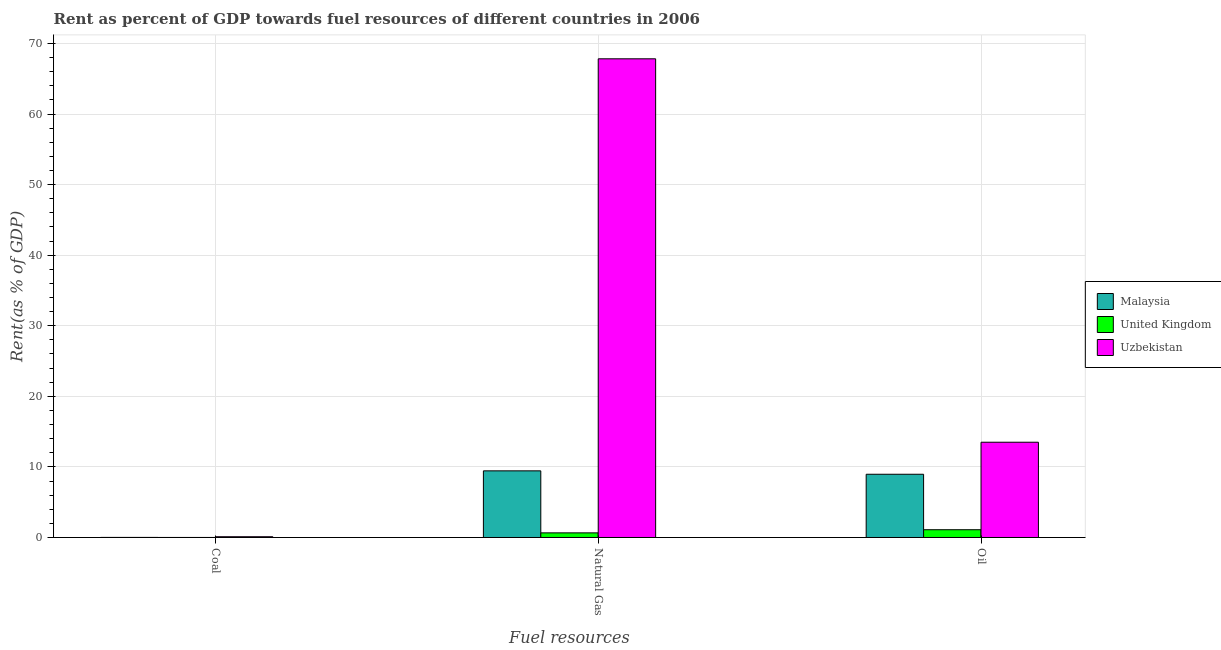How many groups of bars are there?
Your answer should be very brief. 3. Are the number of bars on each tick of the X-axis equal?
Your answer should be compact. Yes. How many bars are there on the 2nd tick from the right?
Your response must be concise. 3. What is the label of the 2nd group of bars from the left?
Give a very brief answer. Natural Gas. What is the rent towards coal in Malaysia?
Provide a succinct answer. 0.01. Across all countries, what is the maximum rent towards natural gas?
Your answer should be very brief. 67.82. Across all countries, what is the minimum rent towards coal?
Offer a terse response. 0. In which country was the rent towards natural gas maximum?
Make the answer very short. Uzbekistan. What is the total rent towards oil in the graph?
Provide a succinct answer. 23.56. What is the difference between the rent towards natural gas in United Kingdom and that in Uzbekistan?
Provide a short and direct response. -67.16. What is the difference between the rent towards natural gas in United Kingdom and the rent towards oil in Uzbekistan?
Offer a very short reply. -12.84. What is the average rent towards coal per country?
Give a very brief answer. 0.04. What is the difference between the rent towards oil and rent towards coal in Malaysia?
Give a very brief answer. 8.95. In how many countries, is the rent towards coal greater than 60 %?
Keep it short and to the point. 0. What is the ratio of the rent towards natural gas in United Kingdom to that in Uzbekistan?
Give a very brief answer. 0.01. What is the difference between the highest and the second highest rent towards oil?
Provide a succinct answer. 4.54. What is the difference between the highest and the lowest rent towards natural gas?
Offer a very short reply. 67.16. In how many countries, is the rent towards oil greater than the average rent towards oil taken over all countries?
Your answer should be compact. 2. What does the 1st bar from the left in Natural Gas represents?
Provide a succinct answer. Malaysia. What does the 3rd bar from the right in Natural Gas represents?
Make the answer very short. Malaysia. Are all the bars in the graph horizontal?
Make the answer very short. No. Are the values on the major ticks of Y-axis written in scientific E-notation?
Offer a very short reply. No. How are the legend labels stacked?
Your response must be concise. Vertical. What is the title of the graph?
Provide a succinct answer. Rent as percent of GDP towards fuel resources of different countries in 2006. Does "Italy" appear as one of the legend labels in the graph?
Offer a terse response. No. What is the label or title of the X-axis?
Your answer should be compact. Fuel resources. What is the label or title of the Y-axis?
Your answer should be compact. Rent(as % of GDP). What is the Rent(as % of GDP) in Malaysia in Coal?
Your answer should be very brief. 0.01. What is the Rent(as % of GDP) of United Kingdom in Coal?
Your response must be concise. 0. What is the Rent(as % of GDP) of Uzbekistan in Coal?
Your answer should be very brief. 0.11. What is the Rent(as % of GDP) in Malaysia in Natural Gas?
Your response must be concise. 9.44. What is the Rent(as % of GDP) of United Kingdom in Natural Gas?
Offer a terse response. 0.66. What is the Rent(as % of GDP) of Uzbekistan in Natural Gas?
Provide a short and direct response. 67.82. What is the Rent(as % of GDP) of Malaysia in Oil?
Provide a succinct answer. 8.96. What is the Rent(as % of GDP) in United Kingdom in Oil?
Your answer should be compact. 1.1. What is the Rent(as % of GDP) of Uzbekistan in Oil?
Your response must be concise. 13.5. Across all Fuel resources, what is the maximum Rent(as % of GDP) of Malaysia?
Keep it short and to the point. 9.44. Across all Fuel resources, what is the maximum Rent(as % of GDP) in United Kingdom?
Provide a short and direct response. 1.1. Across all Fuel resources, what is the maximum Rent(as % of GDP) of Uzbekistan?
Ensure brevity in your answer.  67.82. Across all Fuel resources, what is the minimum Rent(as % of GDP) in Malaysia?
Ensure brevity in your answer.  0.01. Across all Fuel resources, what is the minimum Rent(as % of GDP) in United Kingdom?
Provide a succinct answer. 0. Across all Fuel resources, what is the minimum Rent(as % of GDP) in Uzbekistan?
Keep it short and to the point. 0.11. What is the total Rent(as % of GDP) in Malaysia in the graph?
Provide a succinct answer. 18.41. What is the total Rent(as % of GDP) in United Kingdom in the graph?
Ensure brevity in your answer.  1.76. What is the total Rent(as % of GDP) in Uzbekistan in the graph?
Offer a very short reply. 81.43. What is the difference between the Rent(as % of GDP) of Malaysia in Coal and that in Natural Gas?
Your response must be concise. -9.43. What is the difference between the Rent(as % of GDP) of United Kingdom in Coal and that in Natural Gas?
Your answer should be compact. -0.65. What is the difference between the Rent(as % of GDP) of Uzbekistan in Coal and that in Natural Gas?
Keep it short and to the point. -67.71. What is the difference between the Rent(as % of GDP) in Malaysia in Coal and that in Oil?
Offer a terse response. -8.95. What is the difference between the Rent(as % of GDP) in United Kingdom in Coal and that in Oil?
Provide a succinct answer. -1.1. What is the difference between the Rent(as % of GDP) of Uzbekistan in Coal and that in Oil?
Your answer should be very brief. -13.39. What is the difference between the Rent(as % of GDP) in Malaysia in Natural Gas and that in Oil?
Make the answer very short. 0.48. What is the difference between the Rent(as % of GDP) of United Kingdom in Natural Gas and that in Oil?
Your response must be concise. -0.44. What is the difference between the Rent(as % of GDP) in Uzbekistan in Natural Gas and that in Oil?
Make the answer very short. 54.32. What is the difference between the Rent(as % of GDP) in Malaysia in Coal and the Rent(as % of GDP) in United Kingdom in Natural Gas?
Your answer should be compact. -0.65. What is the difference between the Rent(as % of GDP) of Malaysia in Coal and the Rent(as % of GDP) of Uzbekistan in Natural Gas?
Provide a succinct answer. -67.81. What is the difference between the Rent(as % of GDP) in United Kingdom in Coal and the Rent(as % of GDP) in Uzbekistan in Natural Gas?
Your answer should be very brief. -67.82. What is the difference between the Rent(as % of GDP) of Malaysia in Coal and the Rent(as % of GDP) of United Kingdom in Oil?
Your response must be concise. -1.09. What is the difference between the Rent(as % of GDP) of Malaysia in Coal and the Rent(as % of GDP) of Uzbekistan in Oil?
Offer a very short reply. -13.49. What is the difference between the Rent(as % of GDP) in United Kingdom in Coal and the Rent(as % of GDP) in Uzbekistan in Oil?
Provide a succinct answer. -13.49. What is the difference between the Rent(as % of GDP) in Malaysia in Natural Gas and the Rent(as % of GDP) in United Kingdom in Oil?
Ensure brevity in your answer.  8.34. What is the difference between the Rent(as % of GDP) of Malaysia in Natural Gas and the Rent(as % of GDP) of Uzbekistan in Oil?
Provide a succinct answer. -4.06. What is the difference between the Rent(as % of GDP) in United Kingdom in Natural Gas and the Rent(as % of GDP) in Uzbekistan in Oil?
Provide a succinct answer. -12.84. What is the average Rent(as % of GDP) of Malaysia per Fuel resources?
Offer a terse response. 6.14. What is the average Rent(as % of GDP) in United Kingdom per Fuel resources?
Keep it short and to the point. 0.59. What is the average Rent(as % of GDP) in Uzbekistan per Fuel resources?
Your answer should be very brief. 27.14. What is the difference between the Rent(as % of GDP) in Malaysia and Rent(as % of GDP) in United Kingdom in Coal?
Give a very brief answer. 0.01. What is the difference between the Rent(as % of GDP) in Malaysia and Rent(as % of GDP) in Uzbekistan in Coal?
Your answer should be compact. -0.1. What is the difference between the Rent(as % of GDP) of United Kingdom and Rent(as % of GDP) of Uzbekistan in Coal?
Ensure brevity in your answer.  -0.11. What is the difference between the Rent(as % of GDP) of Malaysia and Rent(as % of GDP) of United Kingdom in Natural Gas?
Offer a terse response. 8.79. What is the difference between the Rent(as % of GDP) of Malaysia and Rent(as % of GDP) of Uzbekistan in Natural Gas?
Give a very brief answer. -58.38. What is the difference between the Rent(as % of GDP) of United Kingdom and Rent(as % of GDP) of Uzbekistan in Natural Gas?
Keep it short and to the point. -67.16. What is the difference between the Rent(as % of GDP) in Malaysia and Rent(as % of GDP) in United Kingdom in Oil?
Keep it short and to the point. 7.86. What is the difference between the Rent(as % of GDP) in Malaysia and Rent(as % of GDP) in Uzbekistan in Oil?
Provide a succinct answer. -4.54. What is the difference between the Rent(as % of GDP) in United Kingdom and Rent(as % of GDP) in Uzbekistan in Oil?
Provide a short and direct response. -12.4. What is the ratio of the Rent(as % of GDP) in Malaysia in Coal to that in Natural Gas?
Keep it short and to the point. 0. What is the ratio of the Rent(as % of GDP) of United Kingdom in Coal to that in Natural Gas?
Make the answer very short. 0. What is the ratio of the Rent(as % of GDP) in Uzbekistan in Coal to that in Natural Gas?
Provide a succinct answer. 0. What is the ratio of the Rent(as % of GDP) of Malaysia in Coal to that in Oil?
Offer a terse response. 0. What is the ratio of the Rent(as % of GDP) in United Kingdom in Coal to that in Oil?
Make the answer very short. 0. What is the ratio of the Rent(as % of GDP) of Uzbekistan in Coal to that in Oil?
Give a very brief answer. 0.01. What is the ratio of the Rent(as % of GDP) in Malaysia in Natural Gas to that in Oil?
Keep it short and to the point. 1.05. What is the ratio of the Rent(as % of GDP) in United Kingdom in Natural Gas to that in Oil?
Offer a terse response. 0.6. What is the ratio of the Rent(as % of GDP) of Uzbekistan in Natural Gas to that in Oil?
Your answer should be compact. 5.02. What is the difference between the highest and the second highest Rent(as % of GDP) in Malaysia?
Give a very brief answer. 0.48. What is the difference between the highest and the second highest Rent(as % of GDP) of United Kingdom?
Give a very brief answer. 0.44. What is the difference between the highest and the second highest Rent(as % of GDP) of Uzbekistan?
Provide a succinct answer. 54.32. What is the difference between the highest and the lowest Rent(as % of GDP) in Malaysia?
Your answer should be very brief. 9.43. What is the difference between the highest and the lowest Rent(as % of GDP) of United Kingdom?
Your answer should be compact. 1.1. What is the difference between the highest and the lowest Rent(as % of GDP) of Uzbekistan?
Offer a terse response. 67.71. 